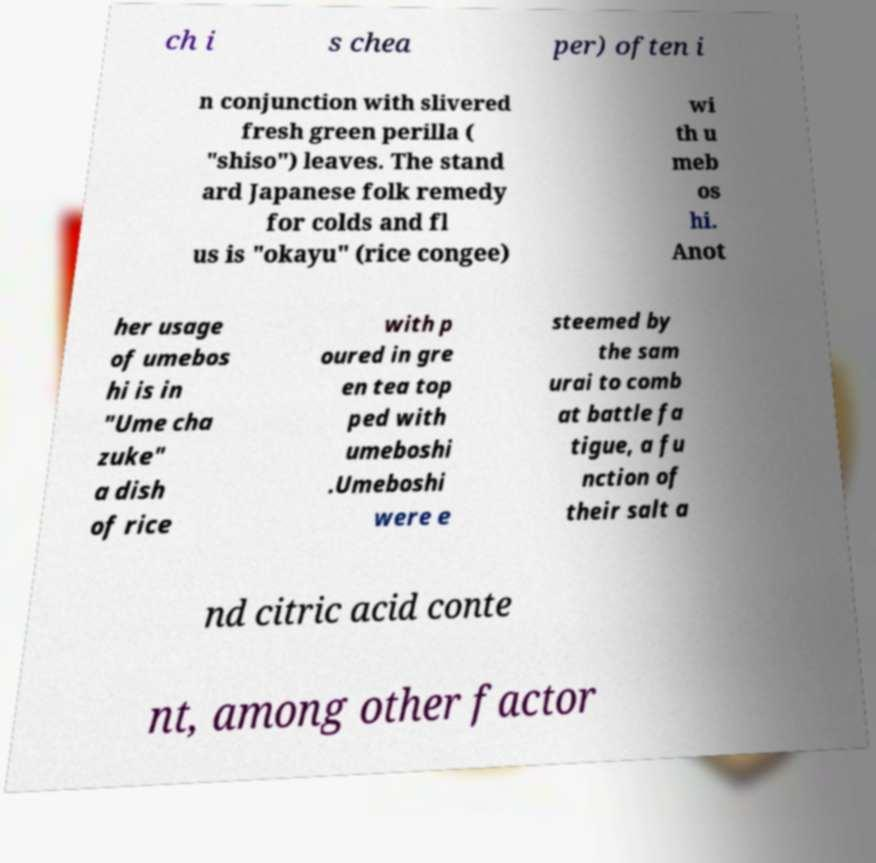What messages or text are displayed in this image? I need them in a readable, typed format. ch i s chea per) often i n conjunction with slivered fresh green perilla ( "shiso") leaves. The stand ard Japanese folk remedy for colds and fl us is "okayu" (rice congee) wi th u meb os hi. Anot her usage of umebos hi is in "Ume cha zuke" a dish of rice with p oured in gre en tea top ped with umeboshi .Umeboshi were e steemed by the sam urai to comb at battle fa tigue, a fu nction of their salt a nd citric acid conte nt, among other factor 